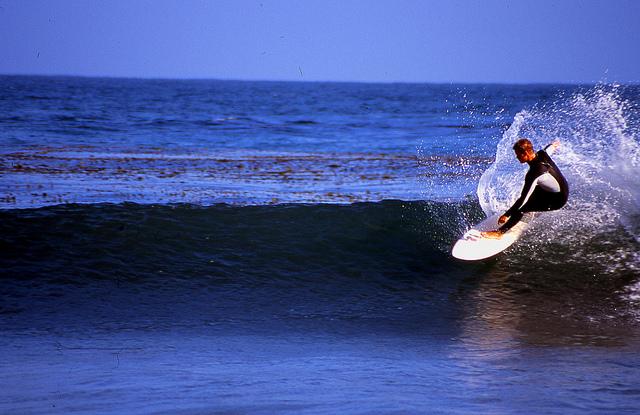Is the surfer African American?
Short answer required. No. Is this a big wave?
Concise answer only. No. What is the man standing on?
Write a very short answer. Surfboard. 